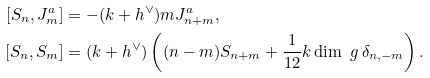Convert formula to latex. <formula><loc_0><loc_0><loc_500><loc_500>[ S _ { n } , J ^ { a } _ { m } ] & = - ( k + h ^ { \vee } ) m J ^ { a } _ { n + m } , \\ [ S _ { n } , S _ { m } ] & = ( k + h ^ { \vee } ) \left ( ( n - m ) S _ { n + m } + \frac { 1 } { 1 2 } k \dim \ g \, \delta _ { n , - m } \right ) .</formula> 